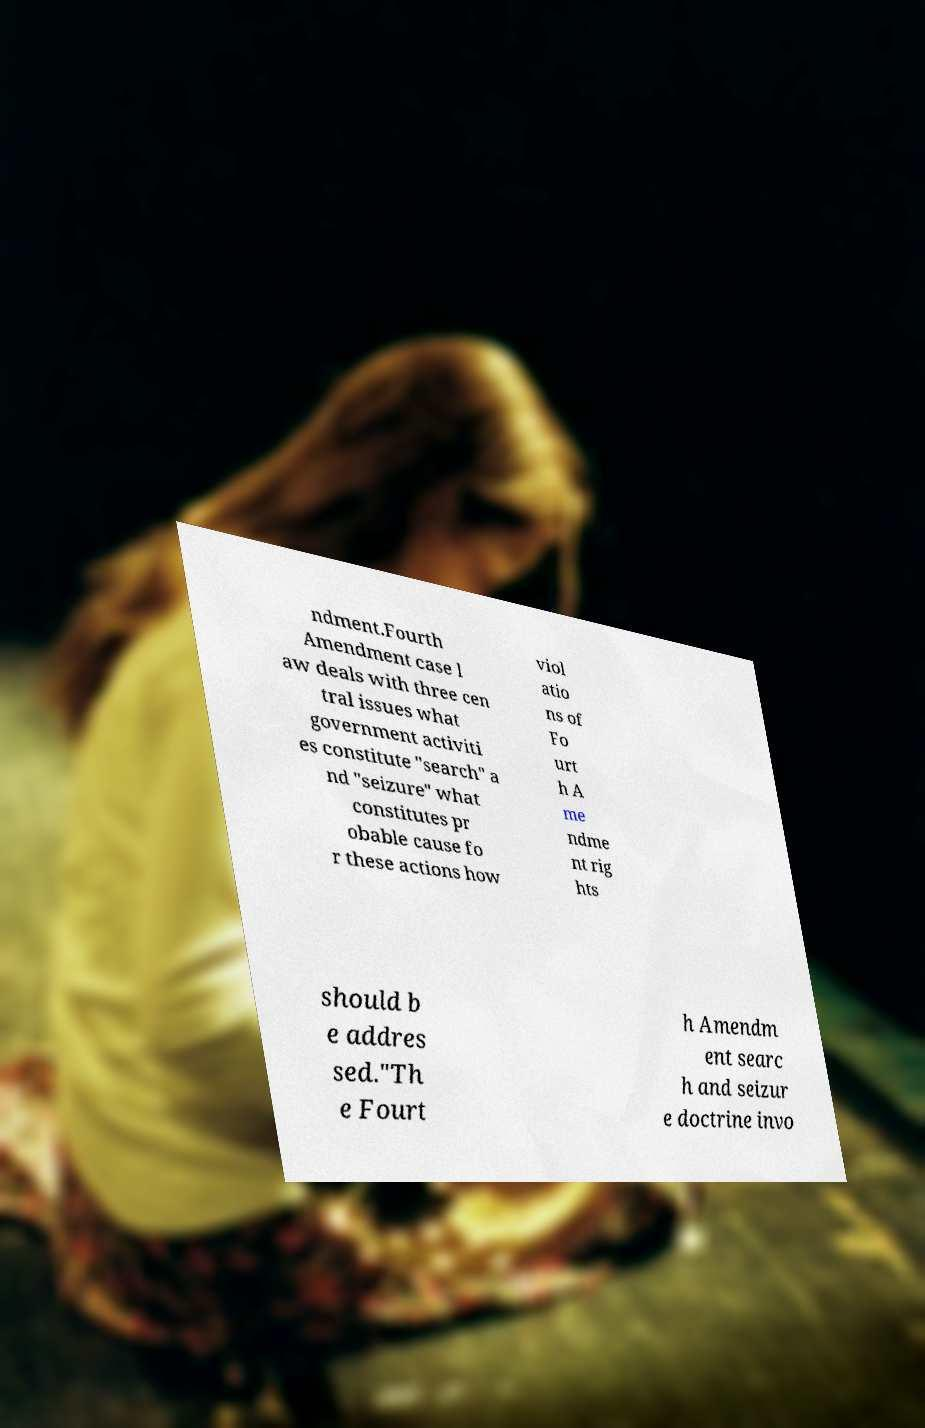Could you extract and type out the text from this image? ndment.Fourth Amendment case l aw deals with three cen tral issues what government activiti es constitute "search" a nd "seizure" what constitutes pr obable cause fo r these actions how viol atio ns of Fo urt h A me ndme nt rig hts should b e addres sed."Th e Fourt h Amendm ent searc h and seizur e doctrine invo 